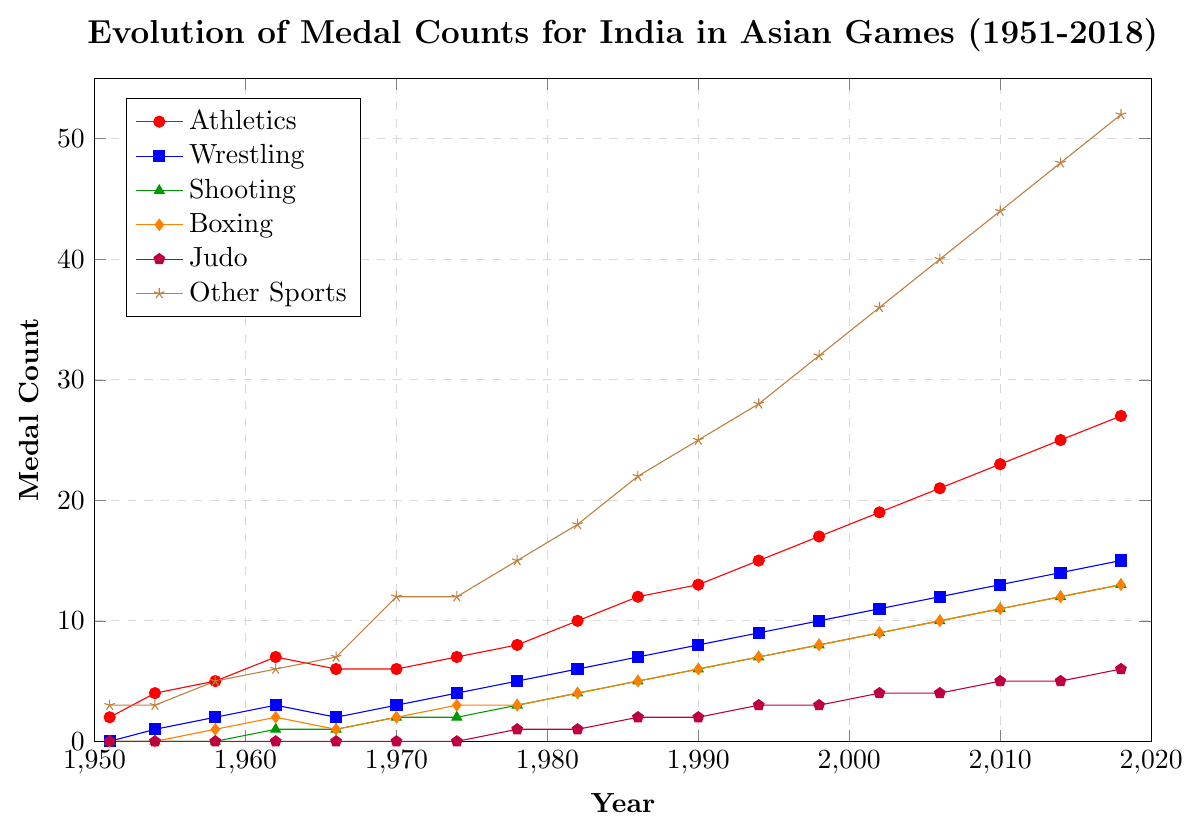How many medals in total did India win in Athletics by 1982? Sum the number of medals in Athletics from 1951 to 1982: 2+4+5+7+6+6+7+8+10
Answer: 55 Which year did India win its first medal in Judo, and how many medals were won? Look for the first non-zero entry in the Judo category and check the corresponding year: In 1978, India won 1 medal in Judo
Answer: 1978, 1 Did Wrestling or Shooting have more medals in 2010? Compare the medal count for Wrestling and Shooting in 2010: Wrestling had 13 medals and Shooting had 11
Answer: Wrestling How many total medals were won by India in 2006 across all sports? Sum the number of medals in each category for the year 2006: 21 (Athletics) + 12 (Wrestling) + 10 (Shooting) + 10 (Boxing) + 4 (Judo) + 40 (Other Sports) = 97
Answer: 97 Which sport had the highest growth in medal count from 1978 to 2018? Subtract the 1978 medal count from the 2018 medal count for each sport and identify the largest difference: 
Athletics: 27-8=19,
Wrestling: 15-5=10,
Shooting: 13-3=10,
Boxing: 13-3=10,
Judo: 6-1=5,
Other Sports: 52-15=37
Answer: Other Sports What is the difference in the total number of medals won in Athletics between 1990 and 2002? Subtract the number of medals in Athletics in 1990 from those in 2002: 19-13=6
Answer: 6 Is the trend in medal counts for Athletics and Boxing similar from 1951 to 2018? Analyze the trend lines for both sports from 1951 to 2018: Both Athletics and Boxing show a generally increasing trend over the years
Answer: Yes In which decade did India show the highest increase in medal count for Other Sports? Compare the increase in medal count for Other Sports across decades and find the highest: 
1971-1980: 15-12=3,
1981-1990: 25-18=7,
1991-2000: 32-25=7,
2001-2010: 44-36=8,
2011-2018: 52-48=4
Answer: 2001-2010 Which sport showed a consistent medal count increment in each Asian Games year from 1951 to 2018? Identify the sport with no decrease in medal count across all years: Athletics shows a consistent increment every term without any decrease
Answer: Athletics 